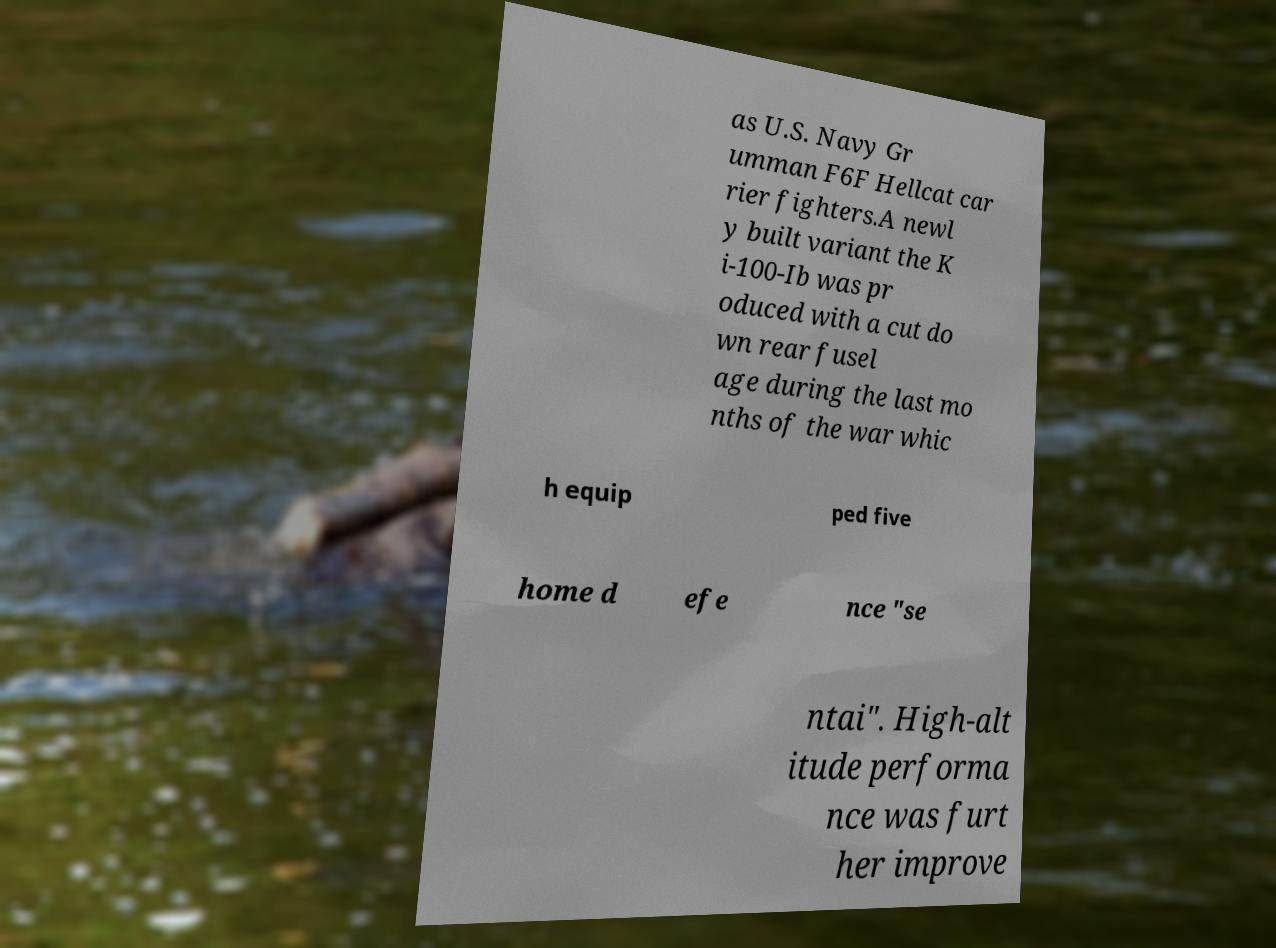What messages or text are displayed in this image? I need them in a readable, typed format. as U.S. Navy Gr umman F6F Hellcat car rier fighters.A newl y built variant the K i-100-Ib was pr oduced with a cut do wn rear fusel age during the last mo nths of the war whic h equip ped five home d efe nce "se ntai". High-alt itude performa nce was furt her improve 